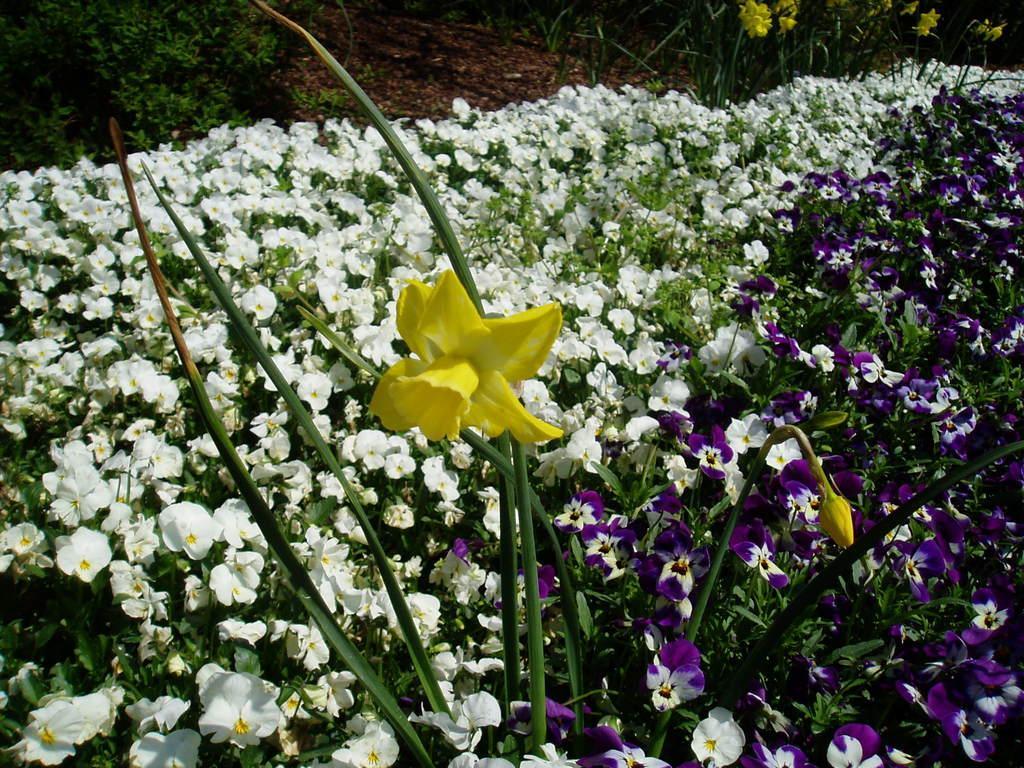Please provide a concise description of this image. In the picture I can see the flowering plants. These are looking like trees on the top left side. 